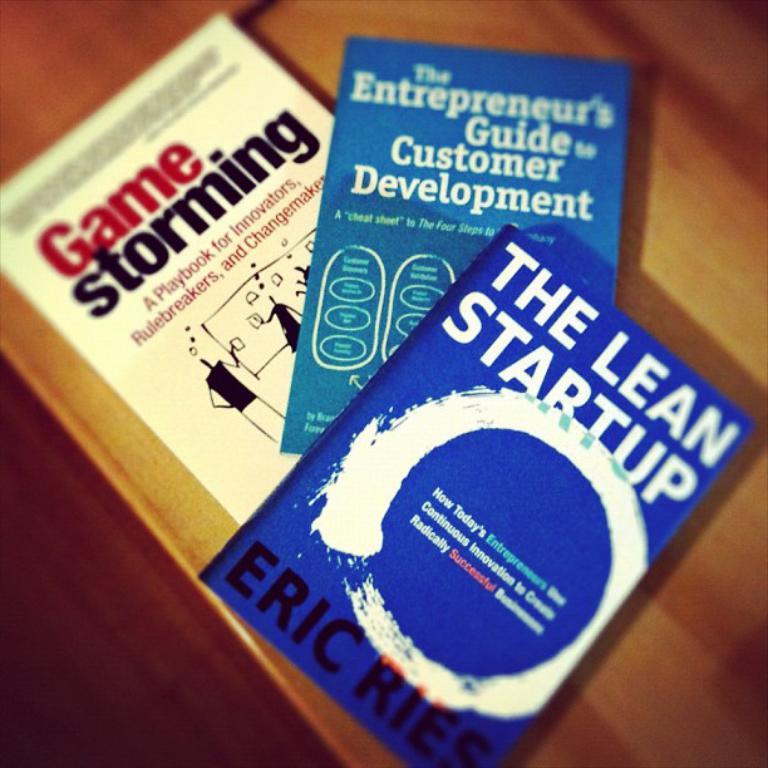What is the title of the white book?
Offer a terse response. Game storming. Who is the author of the blue book?
Offer a terse response. Eric ries. 